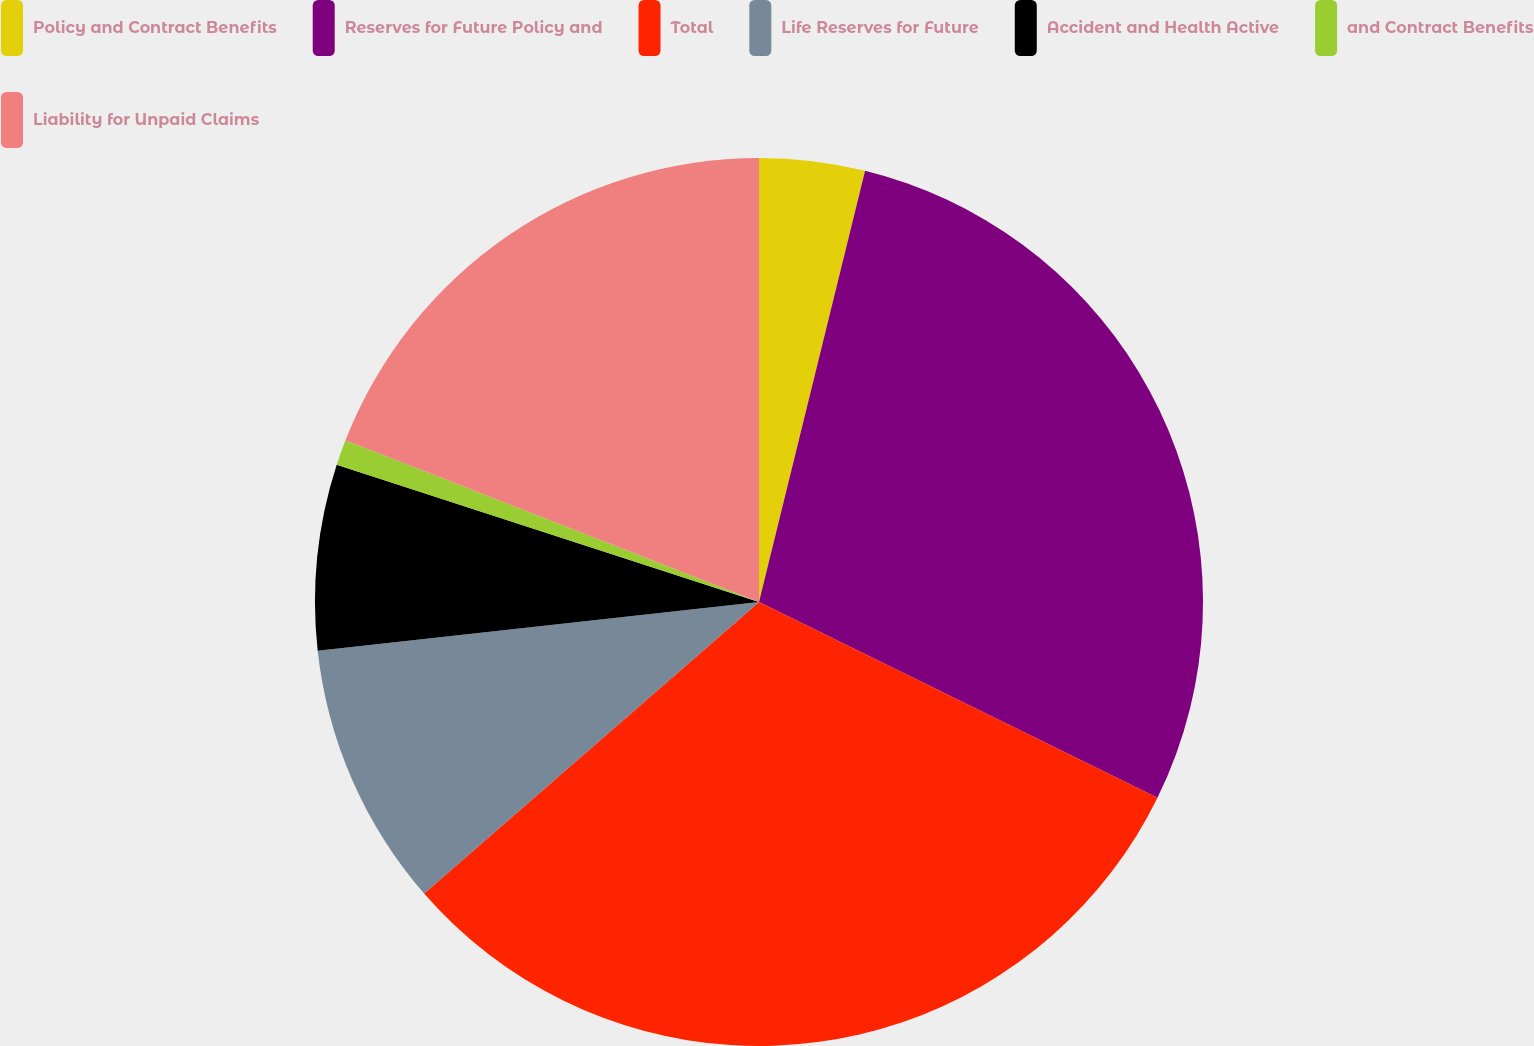Convert chart to OTSL. <chart><loc_0><loc_0><loc_500><loc_500><pie_chart><fcel>Policy and Contract Benefits<fcel>Reserves for Future Policy and<fcel>Total<fcel>Life Reserves for Future<fcel>Accident and Health Active<fcel>and Contract Benefits<fcel>Liability for Unpaid Claims<nl><fcel>3.84%<fcel>28.43%<fcel>31.33%<fcel>9.65%<fcel>6.75%<fcel>0.93%<fcel>19.07%<nl></chart> 